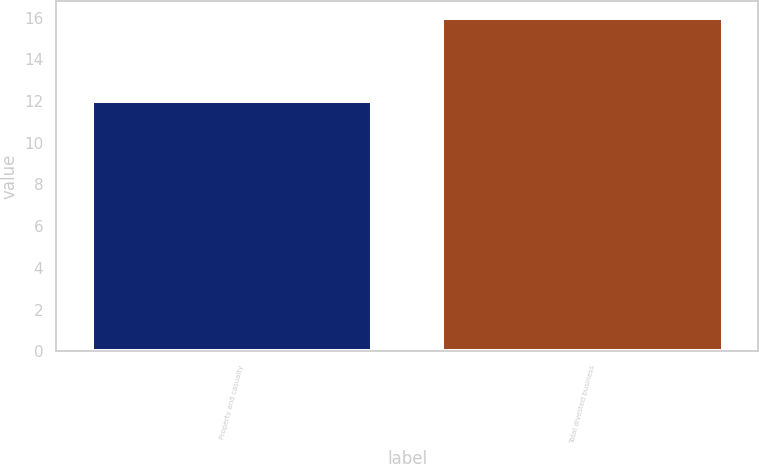Convert chart. <chart><loc_0><loc_0><loc_500><loc_500><bar_chart><fcel>Property and casualty<fcel>Total divested business<nl><fcel>12<fcel>16<nl></chart> 